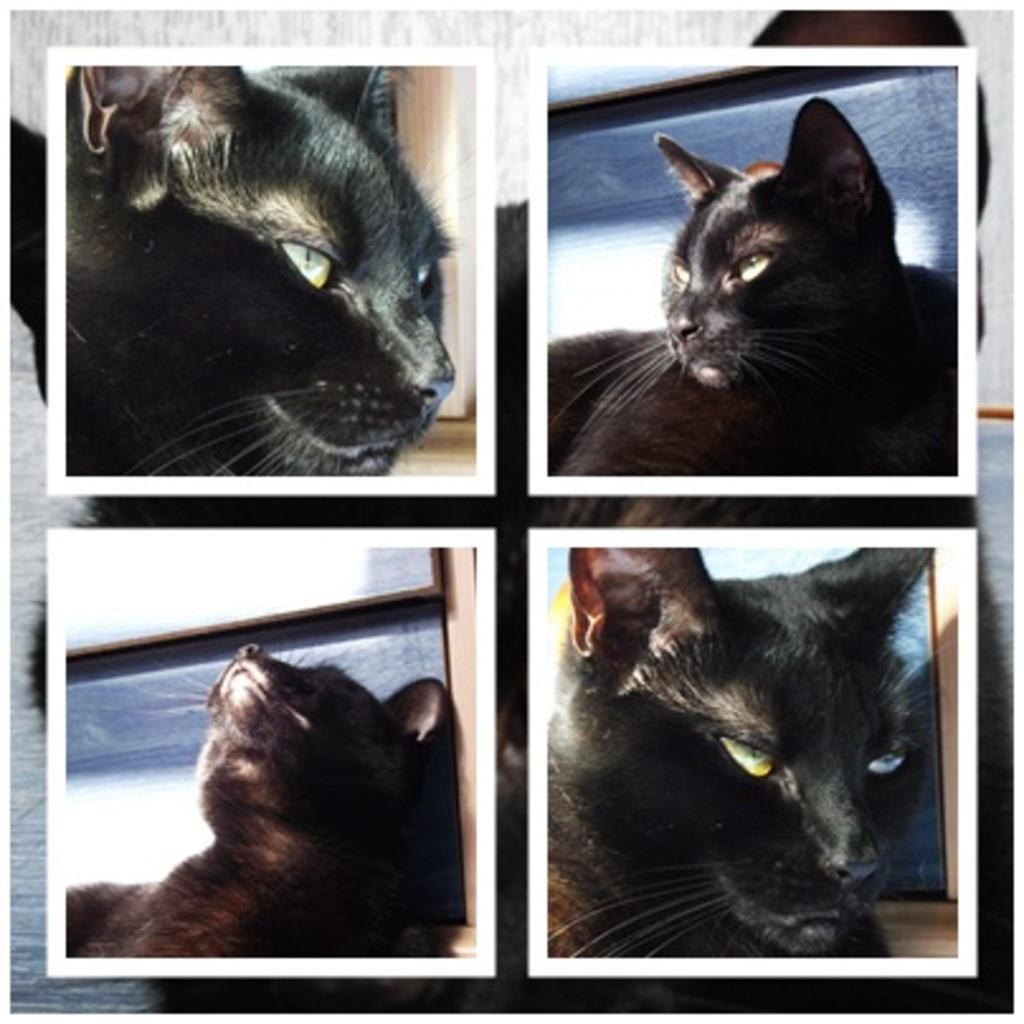In one or two sentences, can you explain what this image depicts? This is a collage picture. Here we can see images of cat. 